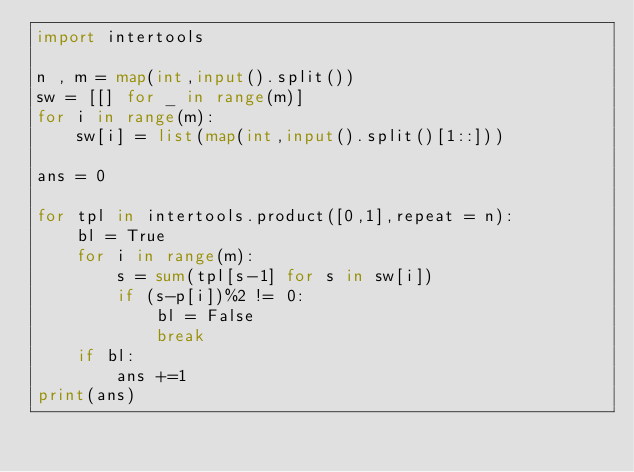Convert code to text. <code><loc_0><loc_0><loc_500><loc_500><_Python_>import intertools

n , m = map(int,input().split())
sw = [[] for _ in range(m)]
for i in range(m):
    sw[i] = list(map(int,input().split()[1::]))

ans = 0

for tpl in intertools.product([0,1],repeat = n):
    bl = True
    for i in range(m):
        s = sum(tpl[s-1] for s in sw[i])
        if (s-p[i])%2 != 0:
            bl = False
            break
    if bl:
        ans +=1
print(ans)</code> 